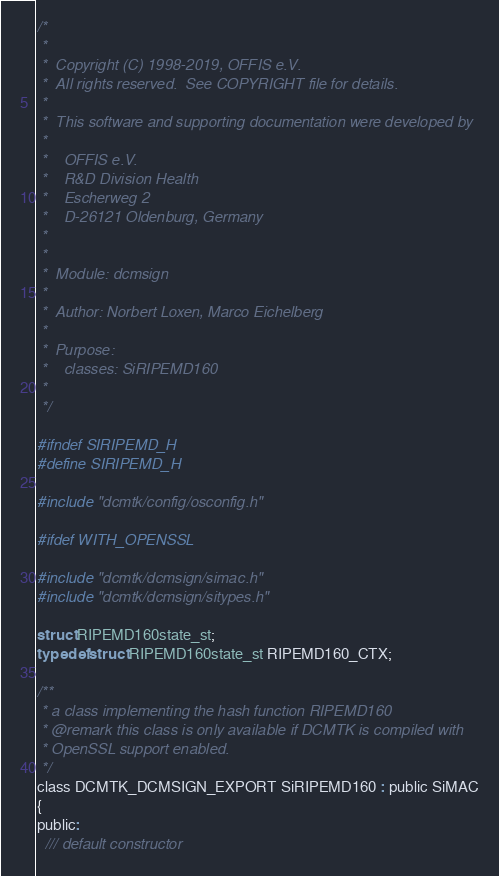Convert code to text. <code><loc_0><loc_0><loc_500><loc_500><_C_>/*
 *
 *  Copyright (C) 1998-2019, OFFIS e.V.
 *  All rights reserved.  See COPYRIGHT file for details.
 *
 *  This software and supporting documentation were developed by
 *
 *    OFFIS e.V.
 *    R&D Division Health
 *    Escherweg 2
 *    D-26121 Oldenburg, Germany
 *
 *
 *  Module: dcmsign
 *
 *  Author: Norbert Loxen, Marco Eichelberg
 *
 *  Purpose:
 *    classes: SiRIPEMD160
 *
 */

#ifndef SIRIPEMD_H
#define SIRIPEMD_H

#include "dcmtk/config/osconfig.h"

#ifdef WITH_OPENSSL

#include "dcmtk/dcmsign/simac.h"
#include "dcmtk/dcmsign/sitypes.h"

struct RIPEMD160state_st;
typedef struct RIPEMD160state_st RIPEMD160_CTX;

/**
 * a class implementing the hash function RIPEMD160
 * @remark this class is only available if DCMTK is compiled with
 * OpenSSL support enabled.
 */
class DCMTK_DCMSIGN_EXPORT SiRIPEMD160 : public SiMAC
{
public:
  /// default constructor</code> 